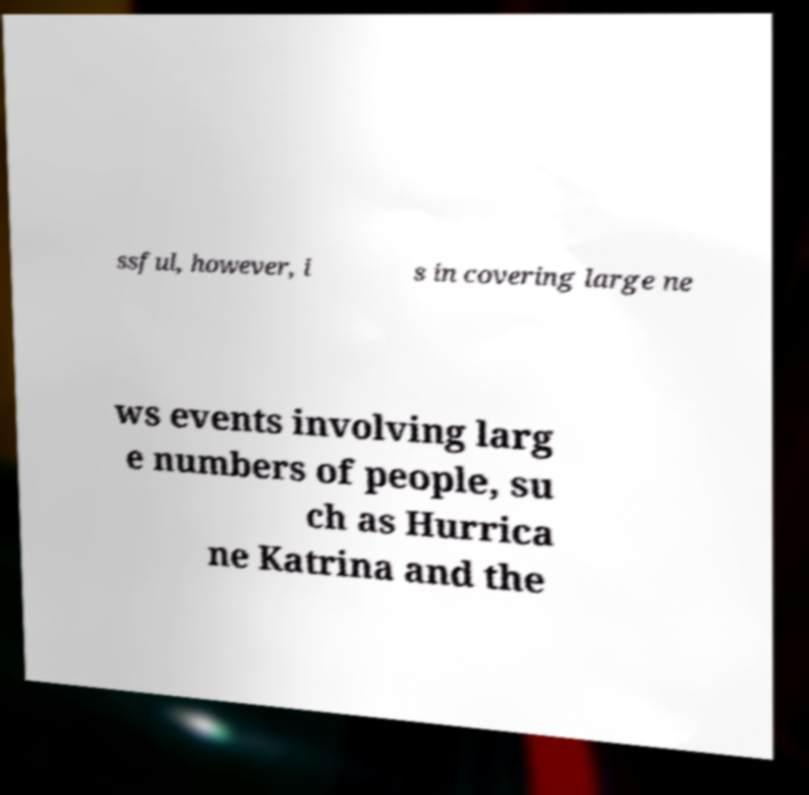Can you accurately transcribe the text from the provided image for me? ssful, however, i s in covering large ne ws events involving larg e numbers of people, su ch as Hurrica ne Katrina and the 